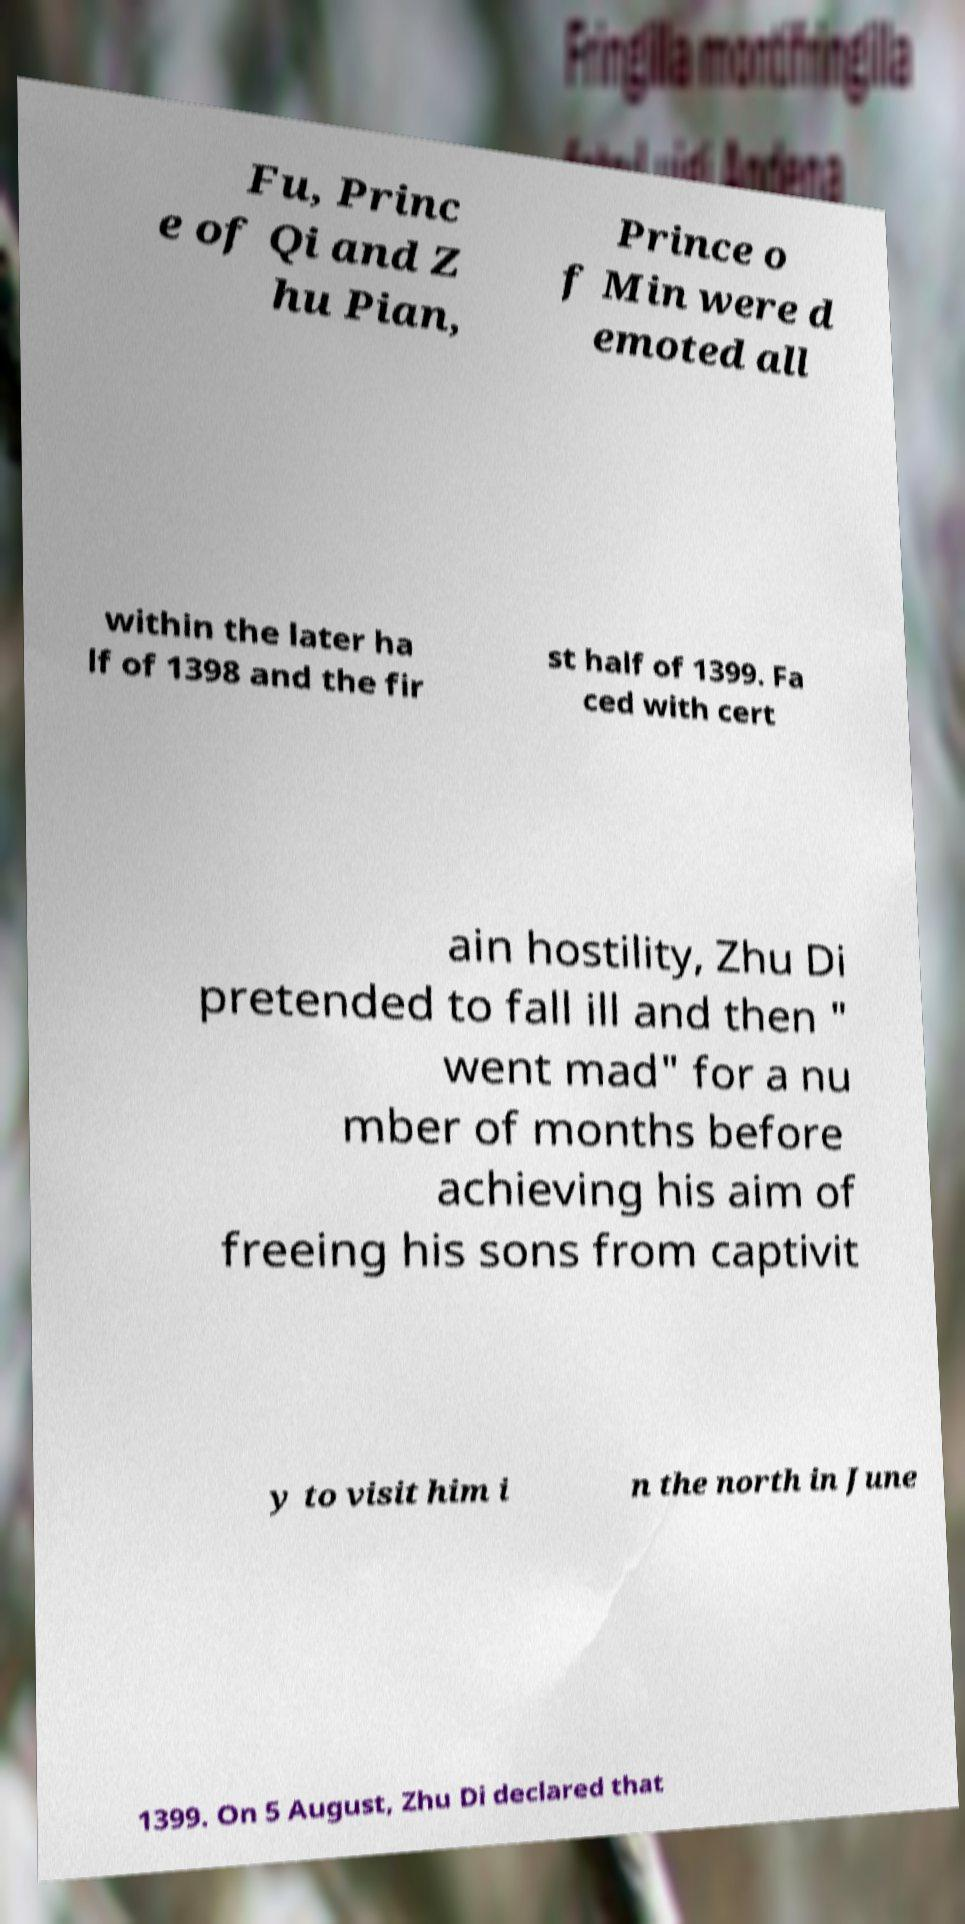Could you extract and type out the text from this image? Fu, Princ e of Qi and Z hu Pian, Prince o f Min were d emoted all within the later ha lf of 1398 and the fir st half of 1399. Fa ced with cert ain hostility, Zhu Di pretended to fall ill and then " went mad" for a nu mber of months before achieving his aim of freeing his sons from captivit y to visit him i n the north in June 1399. On 5 August, Zhu Di declared that 